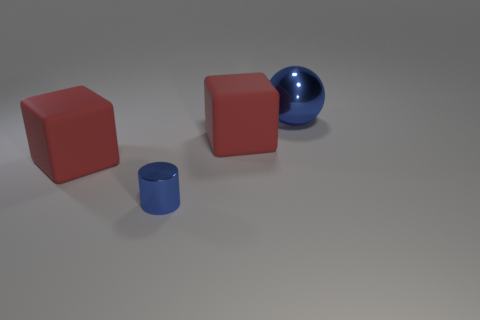Add 1 tiny metallic objects. How many objects exist? 5 Subtract all cylinders. How many objects are left? 3 Add 1 small metallic things. How many small metallic things are left? 2 Add 2 tiny red rubber balls. How many tiny red rubber balls exist? 2 Subtract 0 brown blocks. How many objects are left? 4 Subtract all big red things. Subtract all metal things. How many objects are left? 0 